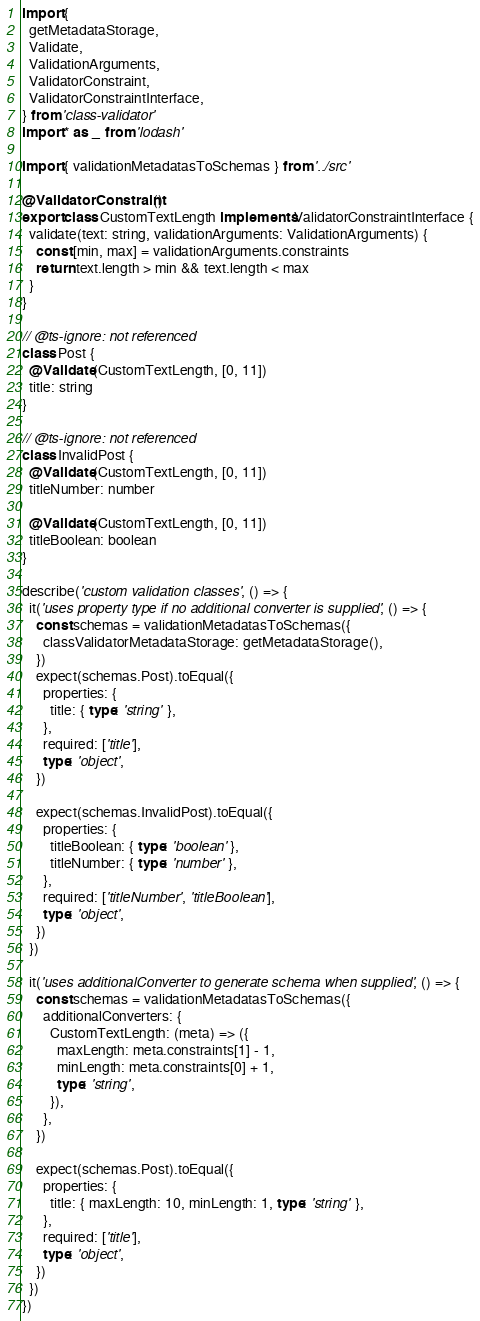<code> <loc_0><loc_0><loc_500><loc_500><_TypeScript_>import {
  getMetadataStorage,
  Validate,
  ValidationArguments,
  ValidatorConstraint,
  ValidatorConstraintInterface,
} from 'class-validator'
import * as _ from 'lodash'

import { validationMetadatasToSchemas } from '../src'

@ValidatorConstraint()
export class CustomTextLength implements ValidatorConstraintInterface {
  validate(text: string, validationArguments: ValidationArguments) {
    const [min, max] = validationArguments.constraints
    return text.length > min && text.length < max
  }
}

// @ts-ignore: not referenced
class Post {
  @Validate(CustomTextLength, [0, 11])
  title: string
}

// @ts-ignore: not referenced
class InvalidPost {
  @Validate(CustomTextLength, [0, 11])
  titleNumber: number

  @Validate(CustomTextLength, [0, 11])
  titleBoolean: boolean
}

describe('custom validation classes', () => {
  it('uses property type if no additional converter is supplied', () => {
    const schemas = validationMetadatasToSchemas({
      classValidatorMetadataStorage: getMetadataStorage(),
    })
    expect(schemas.Post).toEqual({
      properties: {
        title: { type: 'string' },
      },
      required: ['title'],
      type: 'object',
    })

    expect(schemas.InvalidPost).toEqual({
      properties: {
        titleBoolean: { type: 'boolean' },
        titleNumber: { type: 'number' },
      },
      required: ['titleNumber', 'titleBoolean'],
      type: 'object',
    })
  })

  it('uses additionalConverter to generate schema when supplied', () => {
    const schemas = validationMetadatasToSchemas({
      additionalConverters: {
        CustomTextLength: (meta) => ({
          maxLength: meta.constraints[1] - 1,
          minLength: meta.constraints[0] + 1,
          type: 'string',
        }),
      },
    })

    expect(schemas.Post).toEqual({
      properties: {
        title: { maxLength: 10, minLength: 1, type: 'string' },
      },
      required: ['title'],
      type: 'object',
    })
  })
})
</code> 